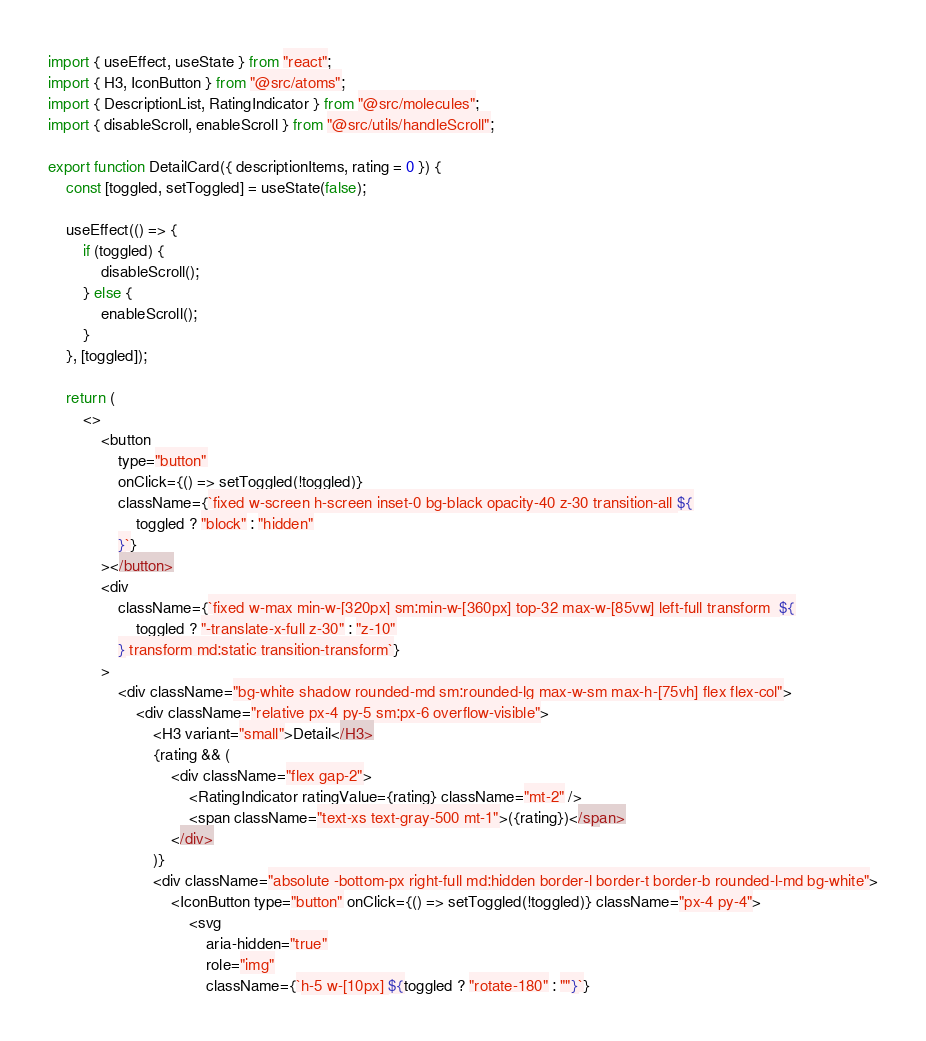Convert code to text. <code><loc_0><loc_0><loc_500><loc_500><_JavaScript_>import { useEffect, useState } from "react";
import { H3, IconButton } from "@src/atoms";
import { DescriptionList, RatingIndicator } from "@src/molecules";
import { disableScroll, enableScroll } from "@src/utils/handleScroll";

export function DetailCard({ descriptionItems, rating = 0 }) {
	const [toggled, setToggled] = useState(false);

	useEffect(() => {
		if (toggled) {
			disableScroll();
		} else {
			enableScroll();
		}
	}, [toggled]);

	return (
		<>
			<button
				type="button"
				onClick={() => setToggled(!toggled)}
				className={`fixed w-screen h-screen inset-0 bg-black opacity-40 z-30 transition-all ${
					toggled ? "block" : "hidden"
				}`}
			></button>
			<div
				className={`fixed w-max min-w-[320px] sm:min-w-[360px] top-32 max-w-[85vw] left-full transform  ${
					toggled ? "-translate-x-full z-30" : "z-10"
				} transform md:static transition-transform`}
			>
				<div className="bg-white shadow rounded-md sm:rounded-lg max-w-sm max-h-[75vh] flex flex-col">
					<div className="relative px-4 py-5 sm:px-6 overflow-visible">
						<H3 variant="small">Detail</H3>
						{rating && (
							<div className="flex gap-2">
								<RatingIndicator ratingValue={rating} className="mt-2" />
								<span className="text-xs text-gray-500 mt-1">({rating})</span>
							</div>
						)}
						<div className="absolute -bottom-px right-full md:hidden border-l border-t border-b rounded-l-md bg-white">
							<IconButton type="button" onClick={() => setToggled(!toggled)} className="px-4 py-4">
								<svg
									aria-hidden="true"
									role="img"
									className={`h-5 w-[10px] ${toggled ? "rotate-180" : ""}`}</code> 